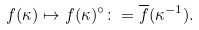<formula> <loc_0><loc_0><loc_500><loc_500>f ( \kappa ) \mapsto f ( \kappa ) ^ { \circ } \colon = \overline { f } ( \kappa ^ { - 1 } ) .</formula> 